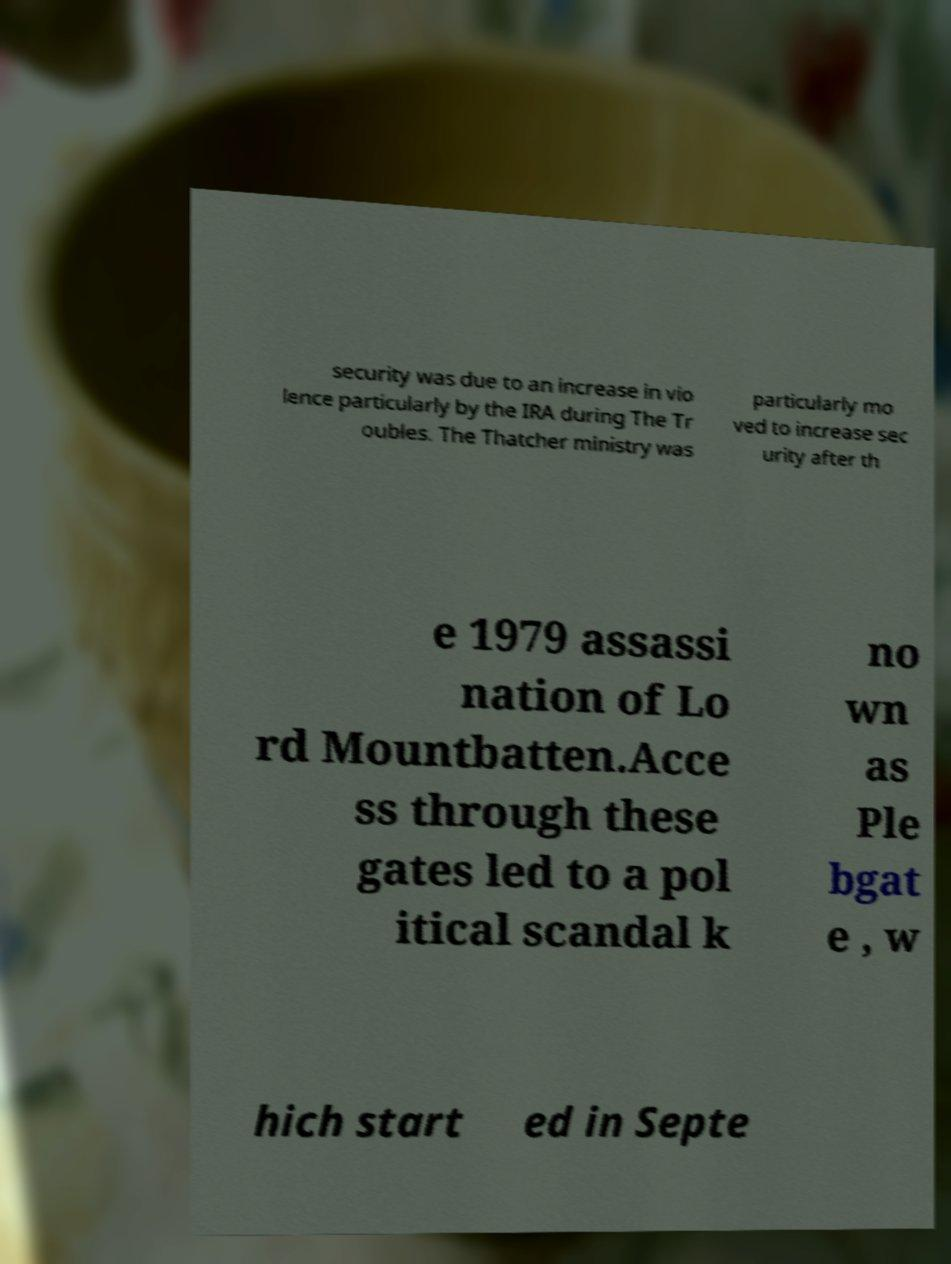There's text embedded in this image that I need extracted. Can you transcribe it verbatim? security was due to an increase in vio lence particularly by the IRA during The Tr oubles. The Thatcher ministry was particularly mo ved to increase sec urity after th e 1979 assassi nation of Lo rd Mountbatten.Acce ss through these gates led to a pol itical scandal k no wn as Ple bgat e , w hich start ed in Septe 